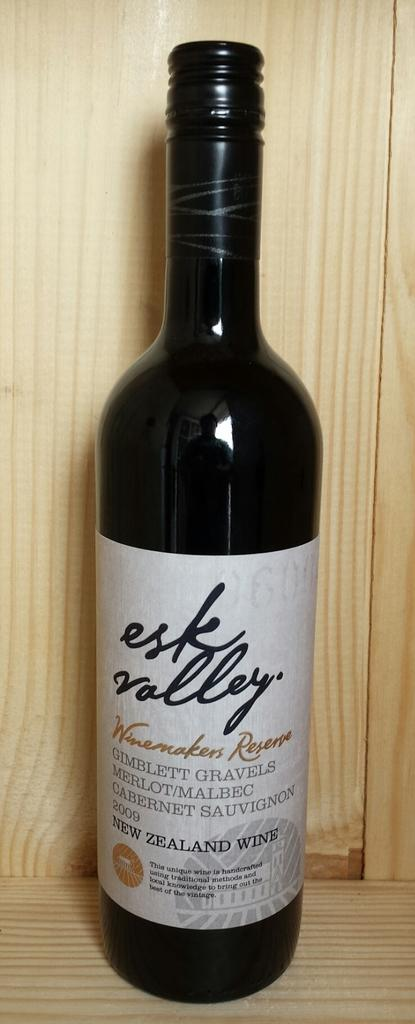<image>
Share a concise interpretation of the image provided. a bottle of esk valley wine is sitting on a shelf 